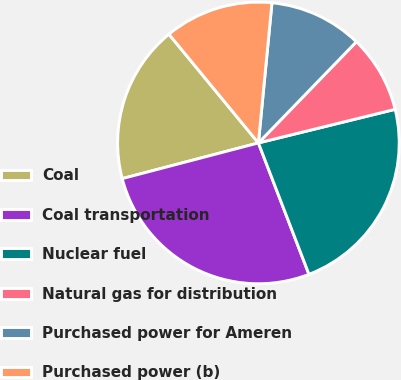Convert chart. <chart><loc_0><loc_0><loc_500><loc_500><pie_chart><fcel>Coal<fcel>Coal transportation<fcel>Nuclear fuel<fcel>Natural gas for distribution<fcel>Purchased power for Ameren<fcel>Purchased power (b)<nl><fcel>18.12%<fcel>26.77%<fcel>22.99%<fcel>8.92%<fcel>10.71%<fcel>12.49%<nl></chart> 